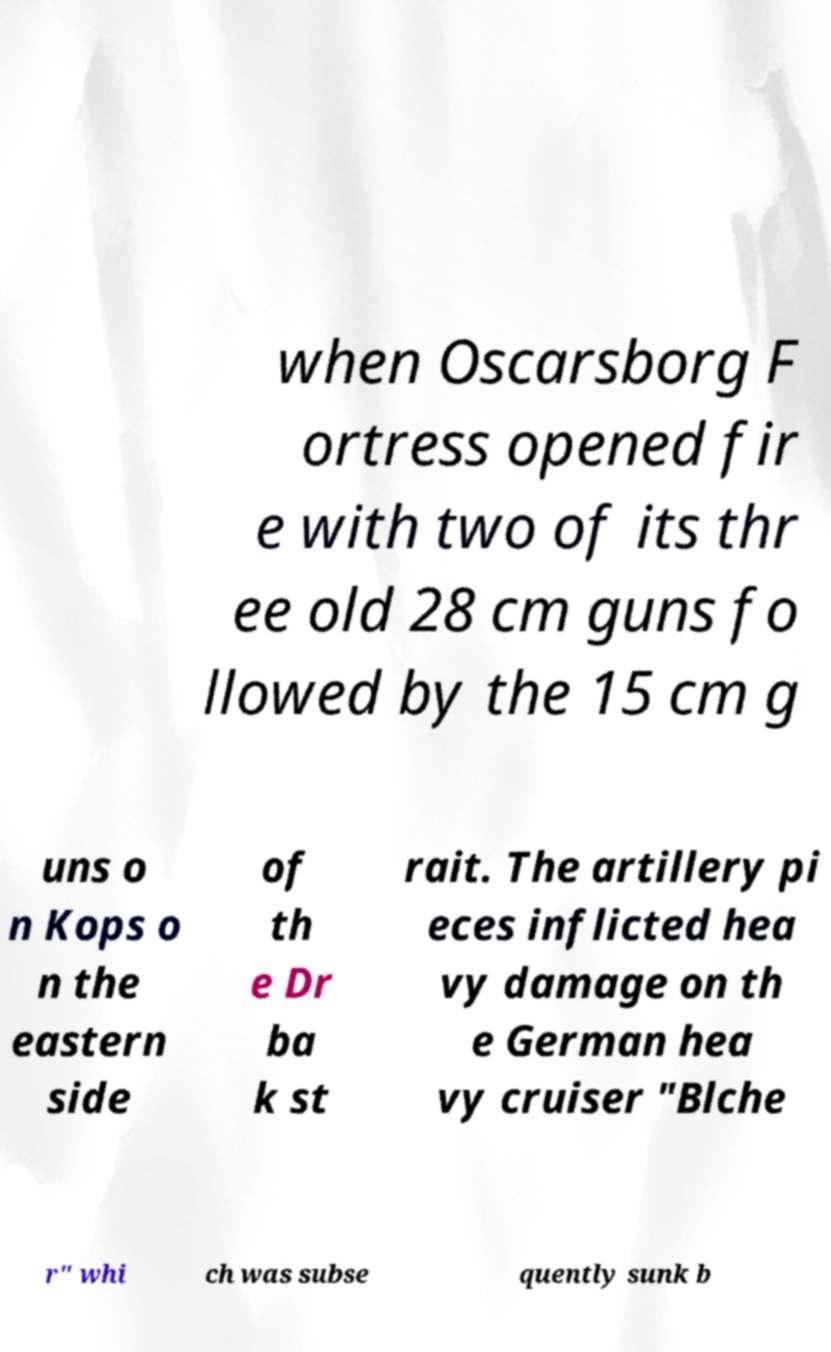What messages or text are displayed in this image? I need them in a readable, typed format. when Oscarsborg F ortress opened fir e with two of its thr ee old 28 cm guns fo llowed by the 15 cm g uns o n Kops o n the eastern side of th e Dr ba k st rait. The artillery pi eces inflicted hea vy damage on th e German hea vy cruiser "Blche r" whi ch was subse quently sunk b 